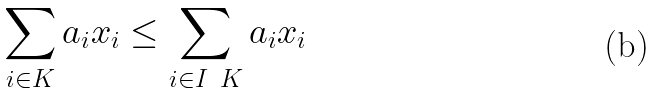Convert formula to latex. <formula><loc_0><loc_0><loc_500><loc_500>\sum _ { i \in K } a _ { i } x _ { i } \leq \sum _ { i \in I \ K } a _ { i } x _ { i }</formula> 